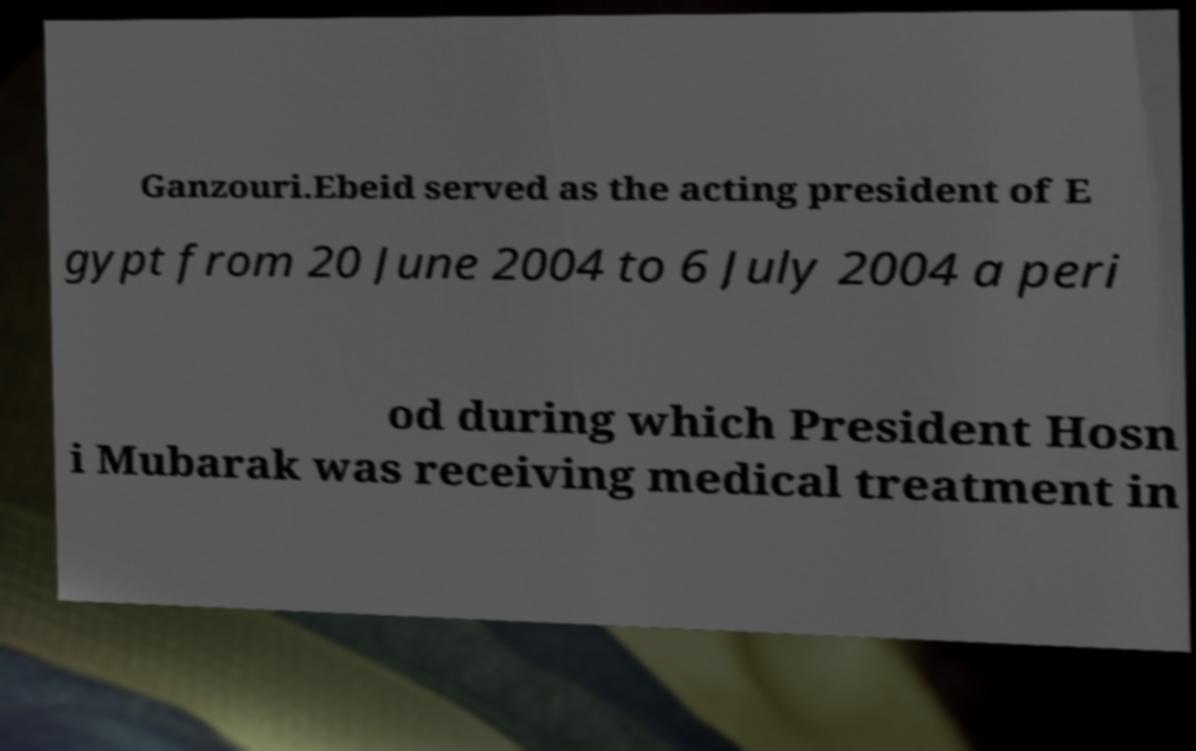Can you read and provide the text displayed in the image?This photo seems to have some interesting text. Can you extract and type it out for me? Ganzouri.Ebeid served as the acting president of E gypt from 20 June 2004 to 6 July 2004 a peri od during which President Hosn i Mubarak was receiving medical treatment in 